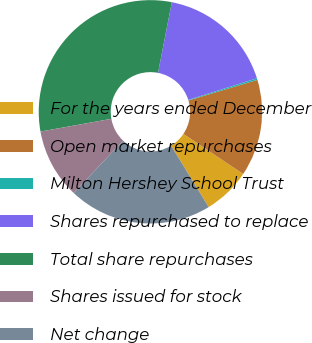<chart> <loc_0><loc_0><loc_500><loc_500><pie_chart><fcel>For the years ended December<fcel>Open market repurchases<fcel>Milton Hershey School Trust<fcel>Shares repurchased to replace<fcel>Total share repurchases<fcel>Shares issued for stock<fcel>Net change<nl><fcel>6.87%<fcel>14.01%<fcel>0.24%<fcel>17.07%<fcel>30.9%<fcel>10.11%<fcel>20.79%<nl></chart> 